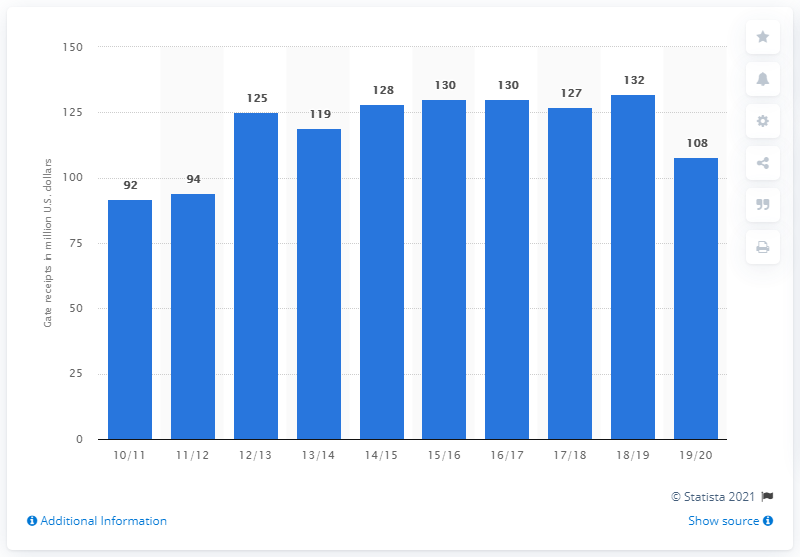Give some essential details in this illustration. In the 2019/20 season, the New York Knicks grossed a total of 108 dollars in gate receipts. 